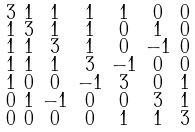<formula> <loc_0><loc_0><loc_500><loc_500>\begin{smallmatrix} 3 & 1 & 1 & 1 & 1 & 0 & 0 \\ 1 & 3 & 1 & 1 & 0 & 1 & 0 \\ 1 & 1 & 3 & 1 & 0 & - 1 & 0 \\ 1 & 1 & 1 & 3 & - 1 & 0 & 0 \\ 1 & 0 & 0 & - 1 & 3 & 0 & 1 \\ 0 & 1 & - 1 & 0 & 0 & 3 & 1 \\ 0 & 0 & 0 & 0 & 1 & 1 & 3 \end{smallmatrix}</formula> 